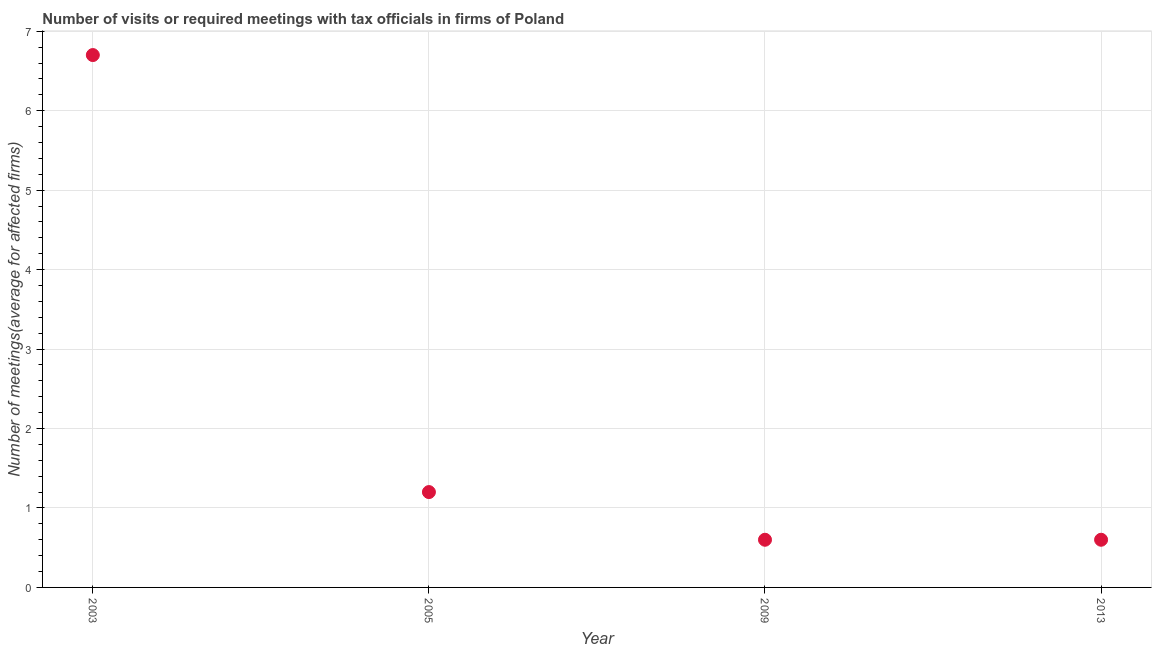Across all years, what is the maximum number of required meetings with tax officials?
Your answer should be compact. 6.7. In which year was the number of required meetings with tax officials minimum?
Keep it short and to the point. 2009. What is the sum of the number of required meetings with tax officials?
Keep it short and to the point. 9.1. What is the average number of required meetings with tax officials per year?
Offer a terse response. 2.27. What is the median number of required meetings with tax officials?
Offer a very short reply. 0.9. Do a majority of the years between 2013 and 2005 (inclusive) have number of required meetings with tax officials greater than 5.6 ?
Your answer should be compact. No. What is the ratio of the number of required meetings with tax officials in 2005 to that in 2009?
Ensure brevity in your answer.  2. Is the number of required meetings with tax officials in 2005 less than that in 2009?
Make the answer very short. No. What is the difference between the highest and the second highest number of required meetings with tax officials?
Your answer should be compact. 5.5. Is the sum of the number of required meetings with tax officials in 2005 and 2013 greater than the maximum number of required meetings with tax officials across all years?
Your response must be concise. No. What is the difference between the highest and the lowest number of required meetings with tax officials?
Your answer should be very brief. 6.1. Does the number of required meetings with tax officials monotonically increase over the years?
Keep it short and to the point. No. How many years are there in the graph?
Give a very brief answer. 4. Are the values on the major ticks of Y-axis written in scientific E-notation?
Your answer should be compact. No. Does the graph contain any zero values?
Offer a very short reply. No. Does the graph contain grids?
Provide a short and direct response. Yes. What is the title of the graph?
Your answer should be compact. Number of visits or required meetings with tax officials in firms of Poland. What is the label or title of the X-axis?
Offer a terse response. Year. What is the label or title of the Y-axis?
Ensure brevity in your answer.  Number of meetings(average for affected firms). What is the Number of meetings(average for affected firms) in 2003?
Ensure brevity in your answer.  6.7. What is the difference between the Number of meetings(average for affected firms) in 2003 and 2005?
Your answer should be compact. 5.5. What is the difference between the Number of meetings(average for affected firms) in 2003 and 2013?
Your answer should be compact. 6.1. What is the difference between the Number of meetings(average for affected firms) in 2009 and 2013?
Your response must be concise. 0. What is the ratio of the Number of meetings(average for affected firms) in 2003 to that in 2005?
Your answer should be very brief. 5.58. What is the ratio of the Number of meetings(average for affected firms) in 2003 to that in 2009?
Your answer should be very brief. 11.17. What is the ratio of the Number of meetings(average for affected firms) in 2003 to that in 2013?
Keep it short and to the point. 11.17. What is the ratio of the Number of meetings(average for affected firms) in 2009 to that in 2013?
Ensure brevity in your answer.  1. 